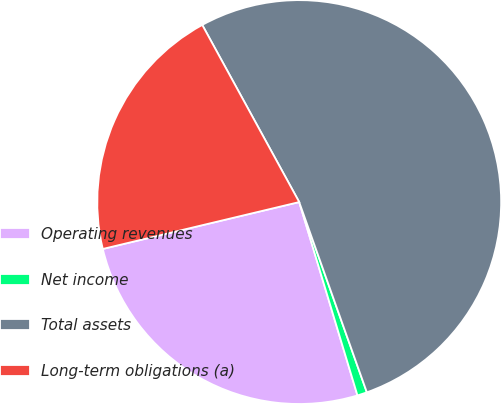<chart> <loc_0><loc_0><loc_500><loc_500><pie_chart><fcel>Operating revenues<fcel>Net income<fcel>Total assets<fcel>Long-term obligations (a)<nl><fcel>25.93%<fcel>0.78%<fcel>52.54%<fcel>20.76%<nl></chart> 